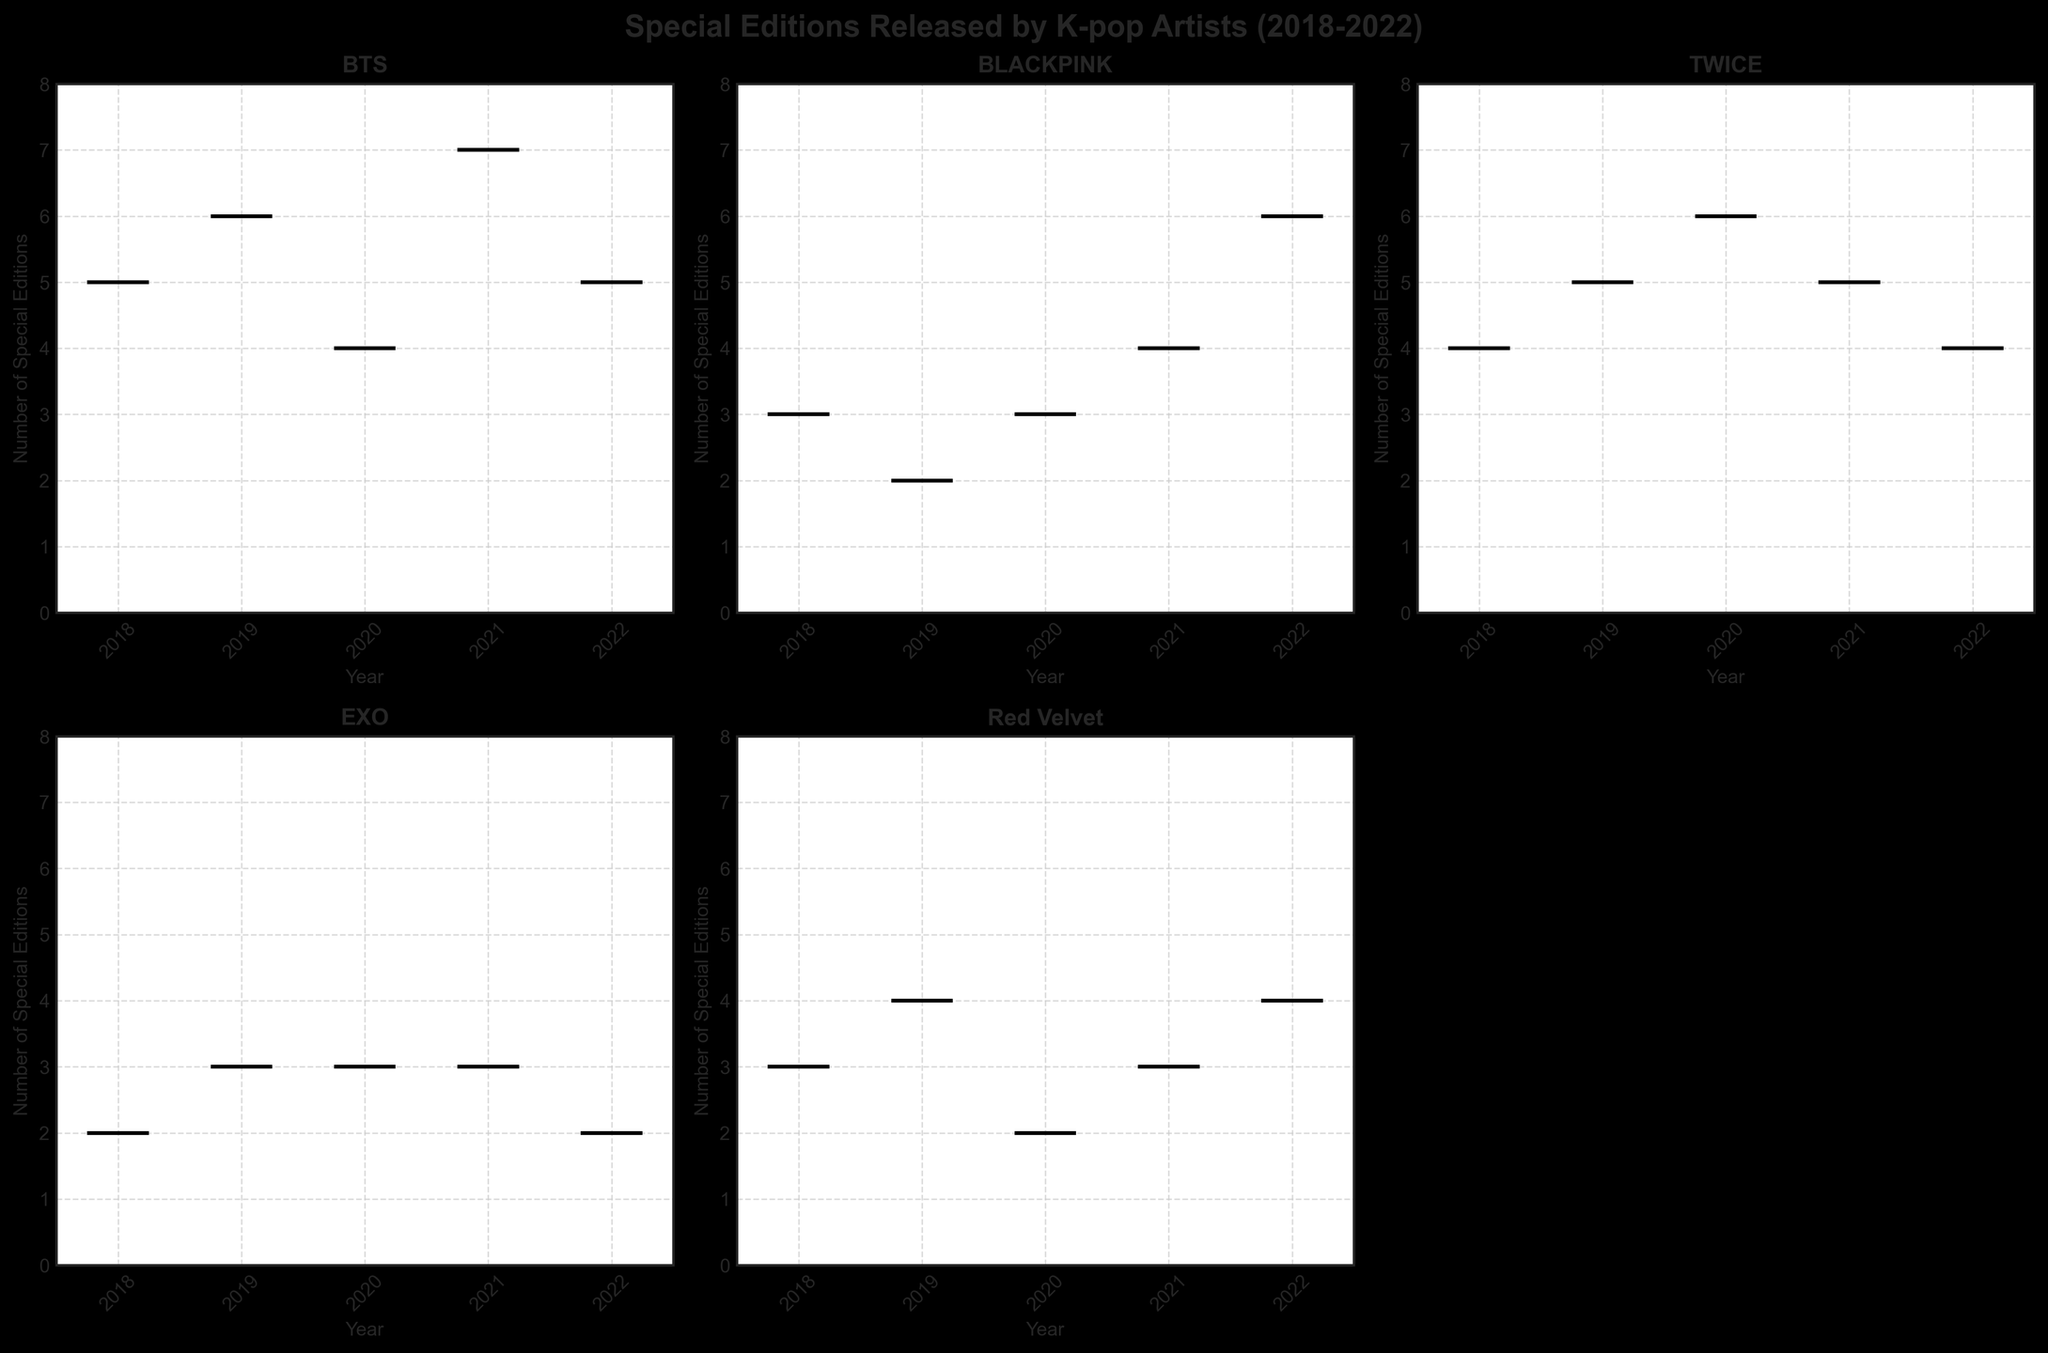What is the title of the figure? The title of the figure is located at the top, centered, and bold. It reads "Special Editions Released by K-pop Artists (2018-2022)".
Answer: Special Editions Released by K-pop Artists (2018-2022) Over which years does this plot present data? The years for which the data is presented can be seen as labels on the x-axes of the subplots. They include the years from 2018 to 2022.
Answer: 2018 to 2022 Which artist released the most special editions in any single year, and how many did they release? BTS released the most special editions in 2021, as seen by the highest box plot median in that year. They released 7 special editions.
Answer: BTS, 7 How many artists are represented in the figure? The figure consists of subplots, each representing different artists. Counting these subplots reveals there are five artists.
Answer: 5 How does the number of special editions released by TWICE in 2020 compare to BLACKPINK in 2022? From the median line in the boxes for the respective years and artists, TWICE released 6 special editions in 2020, while BLACKPINK released 6 in 2022.
Answer: They are equal Which artist had the smallest range of special editions released across the years, and what is the range? By observing the spread and the whiskers of the box plots, EXO had the smallest range. They released between 2 to 3 special editions each year, giving a range of 1.
Answer: EXO, 1 In which year did Red Velvet release the most special editions, and how many did they release? The subplot for Red Velvet shows a peak in the median line of the box plot for the year 2019, where they released 4 special editions.
Answer: 2019, 4 Which artist released fewer special editions in 2019 compared to 2018? Comparing the median lines of the box plots for each year for each artist, BLACKPINK released fewer special editions in 2019 (2) compared to 2018 (3).
Answer: BLACKPINK What is the maximum number of special editions released by BLACKPINK in any given year, and in which year was it released? By examining the box plot for BLACKPINK, the highest median line appears in 2022, where they released 6 special editions.
Answer: 2022, 6 